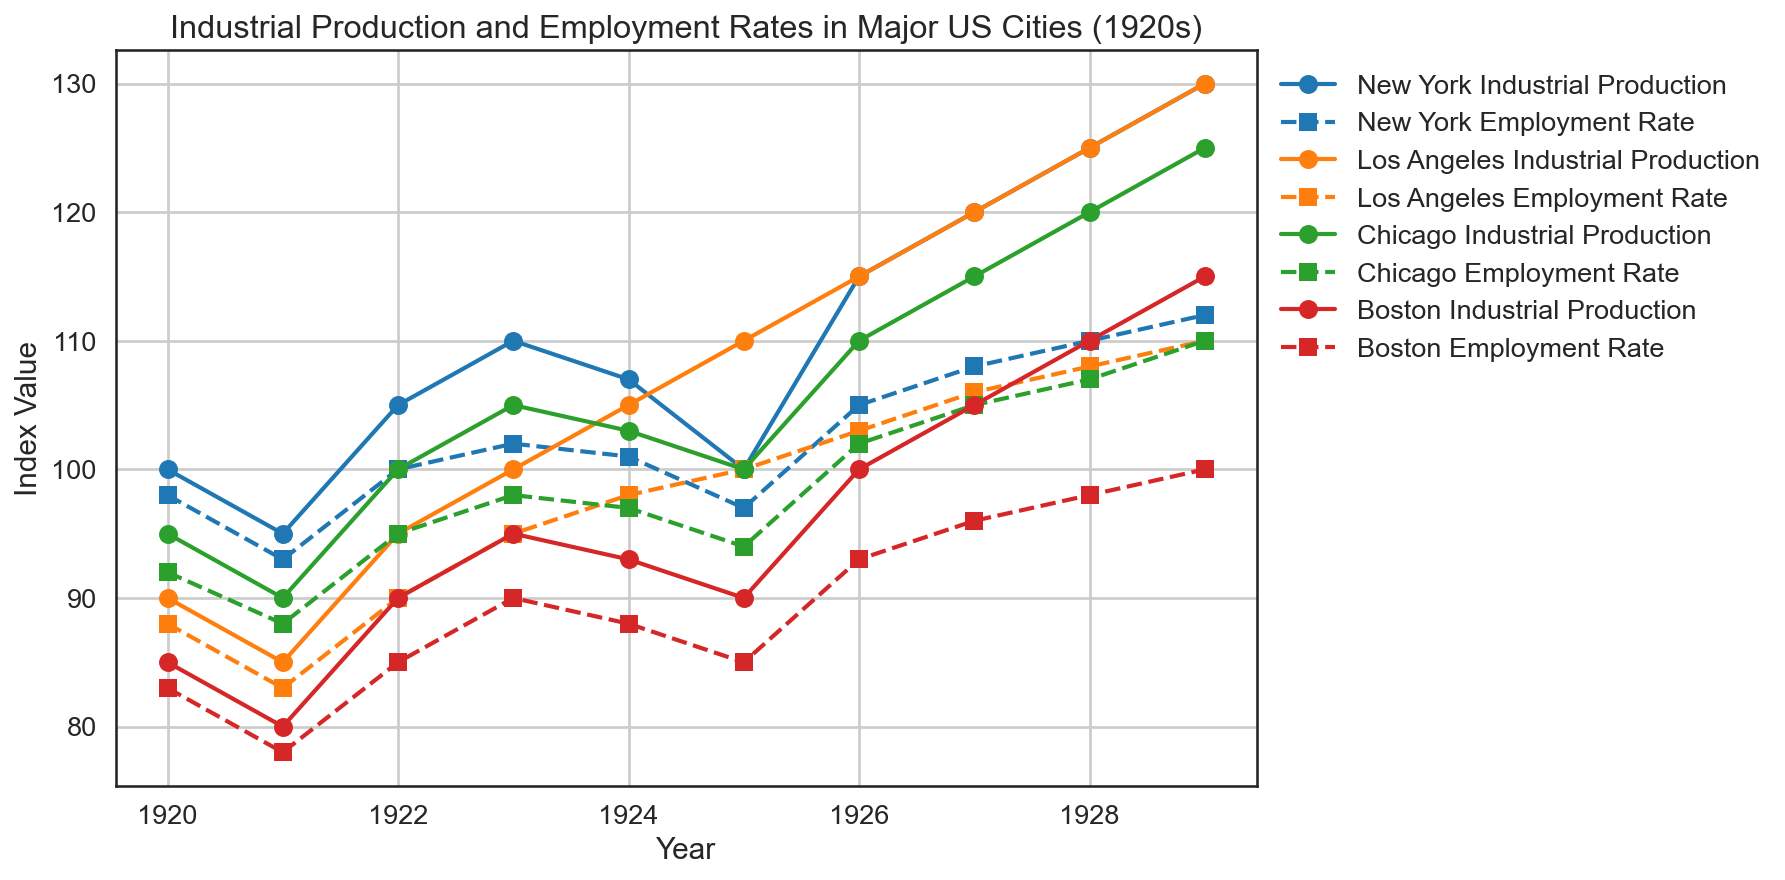Which city had the highest industrial production index in 1929? By looking at the plot, identify the data point at 1929 for all cities. The highest industrial production line corresponds to New York with a value of 130.
Answer: New York Which year did Los Angeles and Chicago both experience equal employment rates? Check the employment rate lines for both Los Angeles and Chicago. They intersect in the year where both cities have the same employment rate. This occurs in 1928 with an employment rate of 108.
Answer: 1928 What is the average industrial production index for Boston from 1920 to 1929? Check the industrial production index values for Boston in the respective years. The values are 85, 80, 90, 95, 93, 90, 100, 105, 110, 115. Sum these values: (85 + 80 + 90 + 95 + 93 + 90 + 100 + 105 + 110 + 115) = 963. Then divide by the number of years, which is 10. Thus, the average is 963/10 = 96.3.
Answer: 96.3 Between 1924 and 1925, did New York’s industrial production increase or decrease? Identify the industrial production values for New York in 1924 and 1925, which are 107 and 100. Since 100 is less than 107, the industrial production decreased.
Answer: Decrease Which city experienced a steady increase in industrial production every year from 1920 to 1929? Observe the industrial production lines for all cities to see which one consistently rises each year. Los Angeles shows a steady increase in its industrial production index each year.
Answer: Los Angeles In which year did New York's employment rate return to its 1920 level? Check New York's employment rate in 1920, which is 98. Look through the following years to find when it is the same again. This happens in 1925 with an employment rate of 97, which is not exactly equal, and 1926 with 105, so it does not return to the exact level.
Answer: It never returns to 98 Which city had the highest employment rate in 1923? Look at the employment rates in 1923 for all cities. The highest employment rate is for New York at 102.
Answer: New York What is the difference in industrial production index between New York and Boston in 1929? Find the industrial production index for New York and Boston in 1929, which are 130 and 115, respectively. Subtract the smaller value from the larger one: 130 - 115 = 15.
Answer: 15 Which city's employment rate trended downward in 1925? Observe the trend lines for employment rates in 1925 for all cities. Boston’s employment rate decreased from 88 in 1924 to 85 in 1925.
Answer: Boston Compare Chicago's industrial production between 1921 and 1924. Did it increase or decrease? Look at Chicago's industrial production in 1921 and 1924, which are 90 and 103 respectively. Since 103 is greater than 90, it increased.
Answer: Increase 